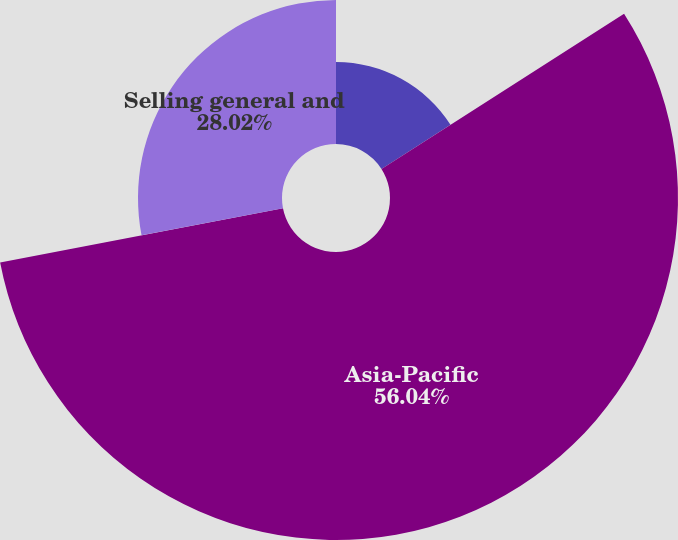Convert chart to OTSL. <chart><loc_0><loc_0><loc_500><loc_500><pie_chart><fcel>Europe<fcel>Asia-Pacific<fcel>Selling general and<nl><fcel>15.94%<fcel>56.04%<fcel>28.02%<nl></chart> 